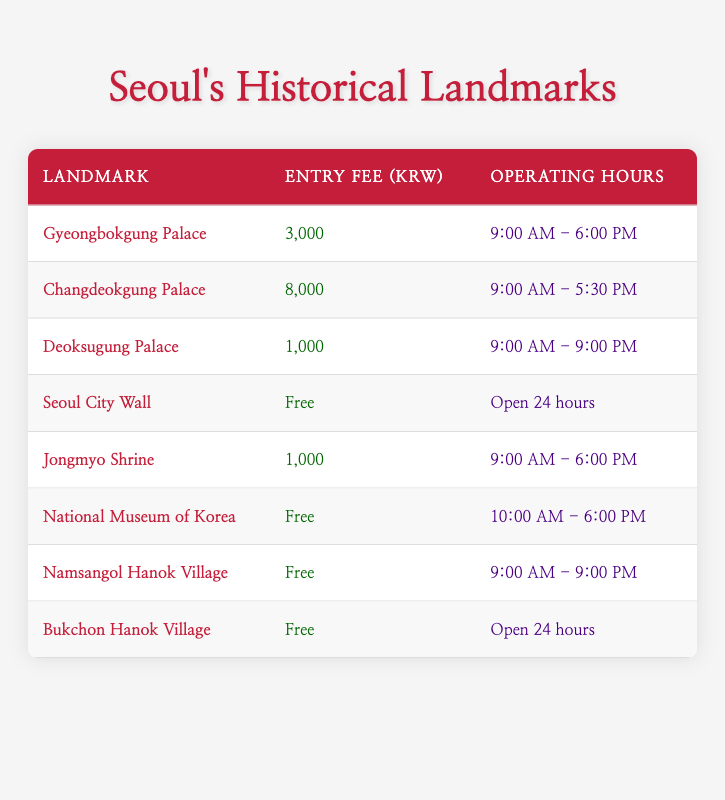What is the entry fee for Gyeongbokgung Palace? The entry fee for Gyeongbokgung Palace is listed in the table under the "Entry Fee (KRW)" column, next to its name. It is 3,000 KRW.
Answer: 3,000 KRW How many historical landmarks have an entry fee of 0 KRW? By reviewing the "Entry Fee (KRW)" column in the table, we see that Seoul City Wall, National Museum of Korea, Namsangol Hanok Village, and Bukchon Hanok Village have an entry fee of 0 KRW. There are four landmarks with free entry.
Answer: 4 What are the operating hours for Changdeokgung Palace? Looking in the "Operating Hours" column next to Changdeokgung Palace's name in the table, we can see that it operates from 9:00 AM to 5:30 PM.
Answer: 9:00 AM - 5:30 PM Is the National Museum of Korea free to enter? Referring to the "Entry Fee (KRW)" column for the National Museum of Korea, it is marked as 0 KRW, indicating that entry is free.
Answer: Yes Which landmark has the longest operating hours? To determine which landmark has the longest operating hours, we compare the hours listed in the "Operating Hours" column. The Seoul City Wall, Bukchon Hanok Village, and the National Museum of Korea operate 24 hours. However, others have specific hours, so these three are the ones with no closing time.
Answer: Seoul City Wall, Bukchon Hanok Village, and National Museum of Korea What is the entry fee difference between Changdeokgung Palace and Deoksugung Palace? The entry fee for Changdeokgung Palace is 8,000 KRW and for Deoksugung Palace is 1,000 KRW. The difference is calculated by subtracting the lower fee from the higher one: 8,000 - 1,000 = 7,000 KRW.
Answer: 7,000 KRW What percentage of the listed landmarks has an entry fee greater than 3,000 KRW? First, we need to identify how many landmarks have an entry fee over 3,000 KRW. Only Changdeokgung Palace (8,000 KRW) and Gyeongbokgung Palace (3,000 KRW) fit this but only Changdeokgung is greater. There are a total of 8 landmarks, so (1/8) * 100 = 12.5%.
Answer: 12.5% Are all the historical sites open every day? By analyzing the "Operating Hours" column, we see that some sites have specific hours, but Seoul City Wall, Namsangol Hanok Village, and Bukchon Hanok Village indicate they are open 24 hours, while others have specified closing hours. Thus, not all sites are open every day.
Answer: No 